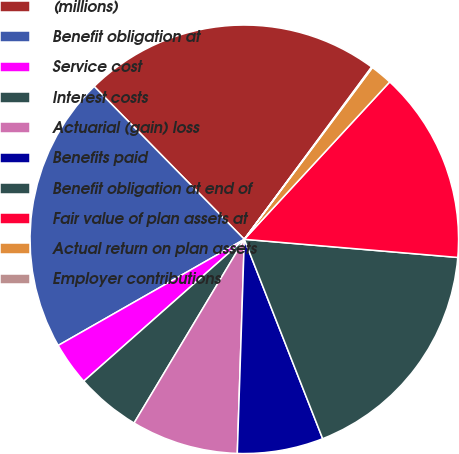Convert chart. <chart><loc_0><loc_0><loc_500><loc_500><pie_chart><fcel>(millions)<fcel>Benefit obligation at<fcel>Service cost<fcel>Interest costs<fcel>Actuarial (gain) loss<fcel>Benefits paid<fcel>Benefit obligation at end of<fcel>Fair value of plan assets at<fcel>Actual return on plan assets<fcel>Employer contributions<nl><fcel>22.49%<fcel>20.89%<fcel>3.27%<fcel>4.88%<fcel>8.08%<fcel>6.48%<fcel>17.69%<fcel>14.48%<fcel>1.67%<fcel>0.07%<nl></chart> 